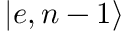Convert formula to latex. <formula><loc_0><loc_0><loc_500><loc_500>\left | e , n - 1 \right \rangle</formula> 